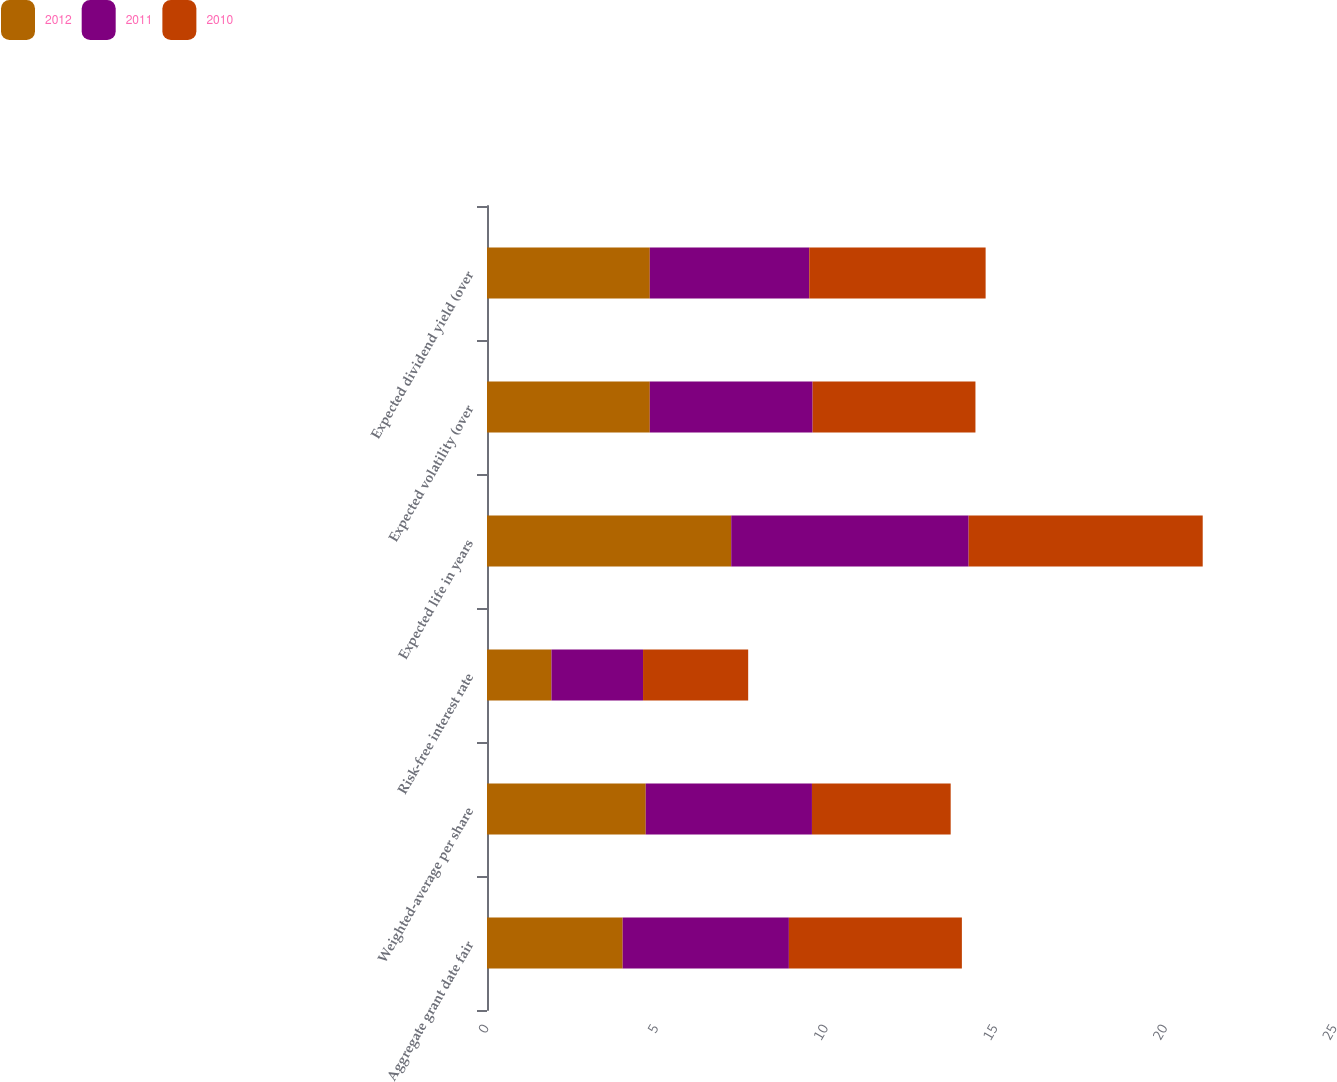Convert chart. <chart><loc_0><loc_0><loc_500><loc_500><stacked_bar_chart><ecel><fcel>Aggregate grant date fair<fcel>Weighted-average per share<fcel>Risk-free interest rate<fcel>Expected life in years<fcel>Expected volatility (over<fcel>Expected dividend yield (over<nl><fcel>2012<fcel>4<fcel>4.68<fcel>1.9<fcel>7.2<fcel>4.8<fcel>4.8<nl><fcel>2011<fcel>4.9<fcel>4.9<fcel>2.7<fcel>7<fcel>4.8<fcel>4.7<nl><fcel>2010<fcel>5.1<fcel>4.09<fcel>3.1<fcel>6.9<fcel>4.8<fcel>5.2<nl></chart> 